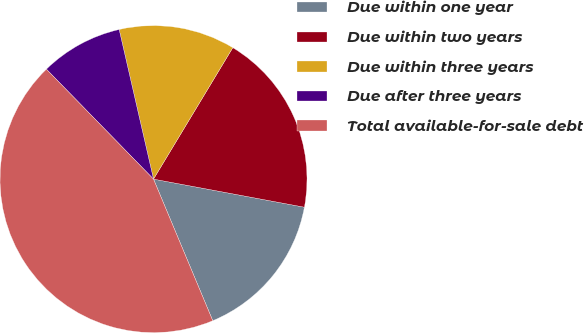Convert chart to OTSL. <chart><loc_0><loc_0><loc_500><loc_500><pie_chart><fcel>Due within one year<fcel>Due within two years<fcel>Due within three years<fcel>Due after three years<fcel>Total available-for-sale debt<nl><fcel>15.76%<fcel>19.29%<fcel>12.23%<fcel>8.7%<fcel>44.01%<nl></chart> 